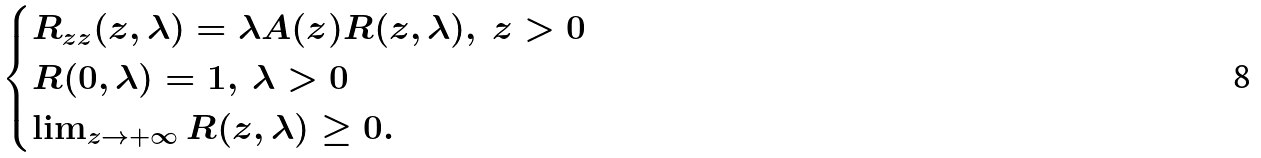<formula> <loc_0><loc_0><loc_500><loc_500>\begin{cases} R _ { z z } ( z , \lambda ) = \lambda A ( z ) R ( z , \lambda ) , \ z > 0 \\ R ( 0 , \lambda ) = 1 , \ \lambda > 0 \\ \lim _ { z \rightarrow { + \infty } } R ( z , \lambda ) \geq 0 . \end{cases}</formula> 